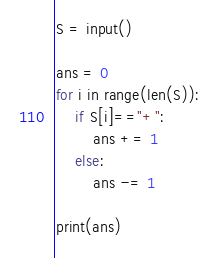<code> <loc_0><loc_0><loc_500><loc_500><_Python_>S = input()

ans = 0
for i in range(len(S)):
    if S[i]=="+":
        ans += 1
    else:
        ans -= 1
        
print(ans)</code> 